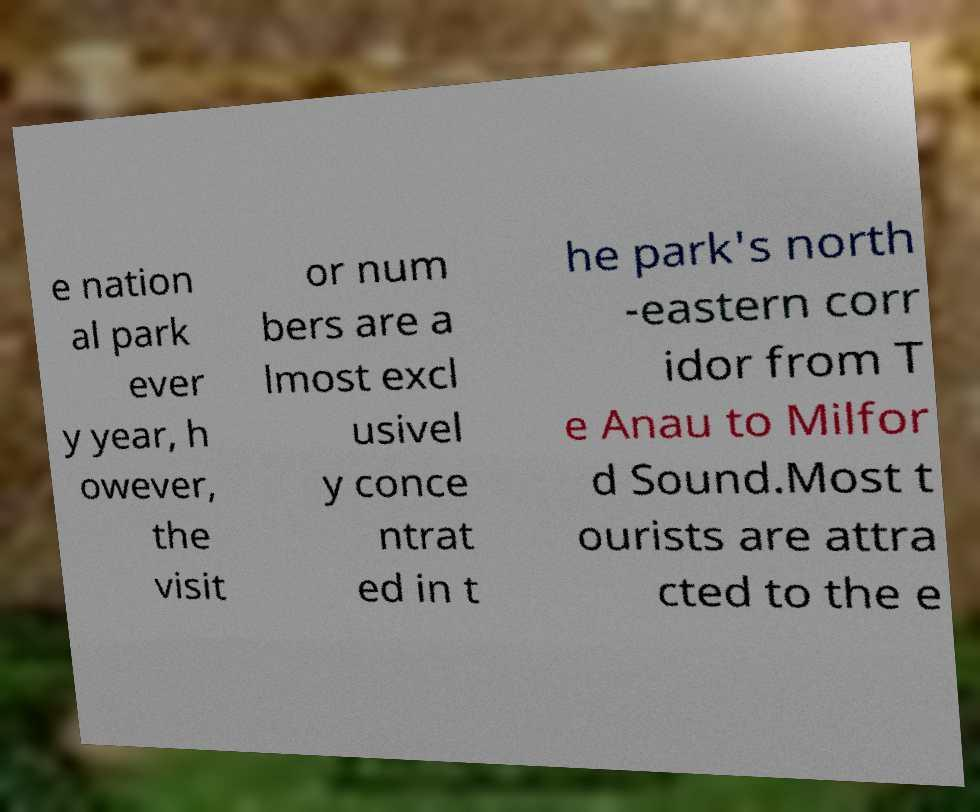Can you read and provide the text displayed in the image?This photo seems to have some interesting text. Can you extract and type it out for me? e nation al park ever y year, h owever, the visit or num bers are a lmost excl usivel y conce ntrat ed in t he park's north -eastern corr idor from T e Anau to Milfor d Sound.Most t ourists are attra cted to the e 